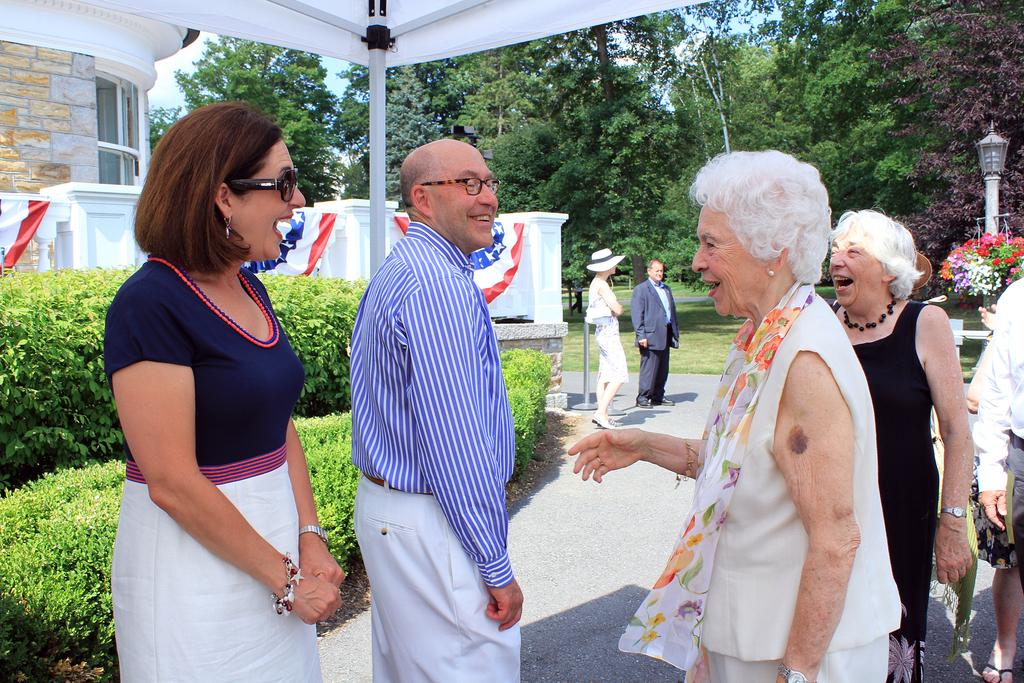How many people are in the image? There are multiple persons in the image. What type of vegetation is on the left side of the image? There are bushes on the left side of the image. What can be seen at the top of the image? There are trees at the top of the image. What type of structure is on the left side of the image? There is a building on the left side of the image. What is the process of the acoustics in the image? There is no specific process or acoustics mentioned in the image, as it primarily features persons, bushes, trees, and a building. 